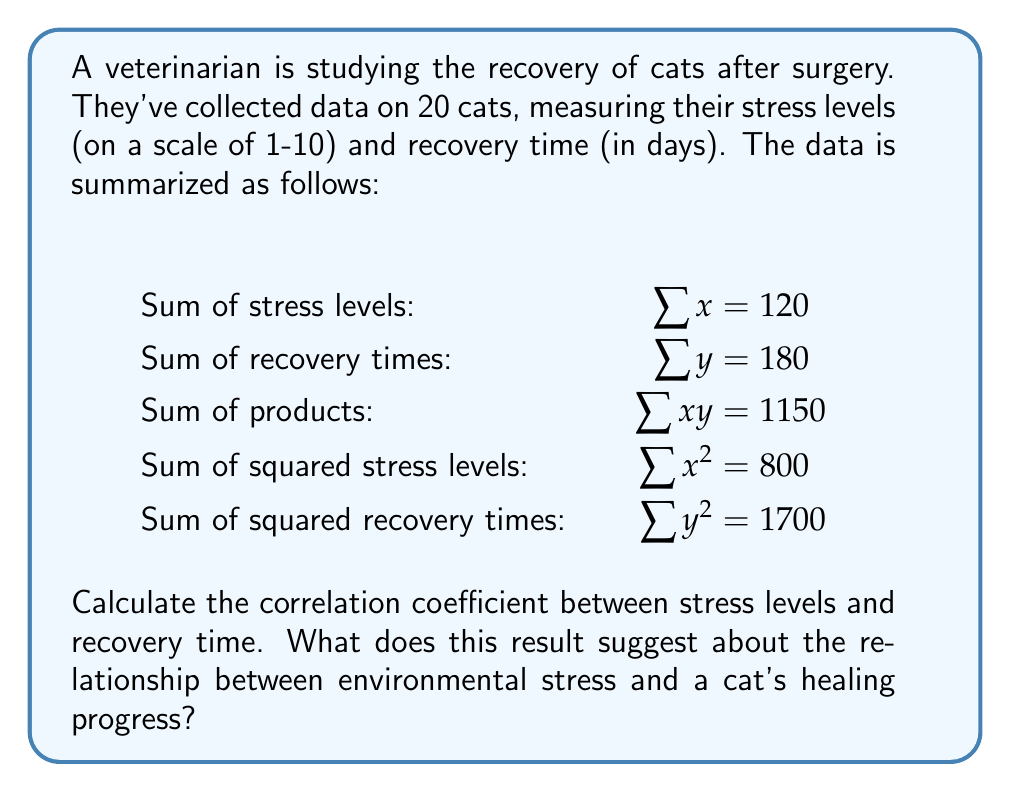Solve this math problem. To calculate the correlation coefficient, we'll use the Pearson correlation formula:

$$r = \frac{n\sum xy - \sum x \sum y}{\sqrt{[n\sum x^2 - (\sum x)^2][n\sum y^2 - (\sum y)^2]}}$$

Where:
$n$ = number of cats = 20
$\sum x$ = sum of stress levels = 120
$\sum y$ = sum of recovery times = 180
$\sum xy$ = sum of products = 1150
$\sum x^2$ = sum of squared stress levels = 800
$\sum y^2$ = sum of squared recovery times = 1700

Step 1: Calculate the numerator
$20 * 1150 - 120 * 180 = 23000 - 21600 = 1400$

Step 2: Calculate the first part of the denominator
$20 * 800 - 120^2 = 16000 - 14400 = 1600$

Step 3: Calculate the second part of the denominator
$20 * 1700 - 180^2 = 34000 - 32400 = 1600$

Step 4: Multiply the parts of the denominator
$\sqrt{1600 * 1600} = \sqrt{2560000} = 1600$

Step 5: Divide the numerator by the denominator
$r = \frac{1400}{1600} = 0.875$

The correlation coefficient is 0.875, which indicates a strong positive correlation between stress levels and recovery time.

This suggests that as environmental stress increases, the cat's healing progress tends to slow down, resulting in longer recovery times. For a nervous cat owner, this emphasizes the importance of minimizing stress factors in the cat's environment to promote faster healing after surgery.
Answer: $r = 0.875$, indicating a strong positive correlation between stress and recovery time. 